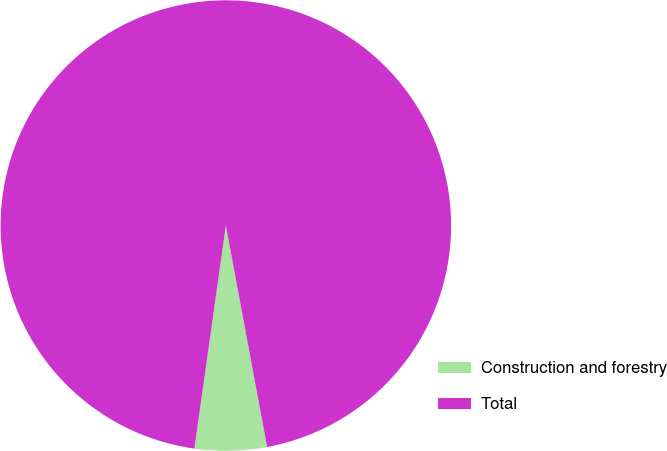Convert chart to OTSL. <chart><loc_0><loc_0><loc_500><loc_500><pie_chart><fcel>Construction and forestry<fcel>Total<nl><fcel>5.16%<fcel>94.84%<nl></chart> 